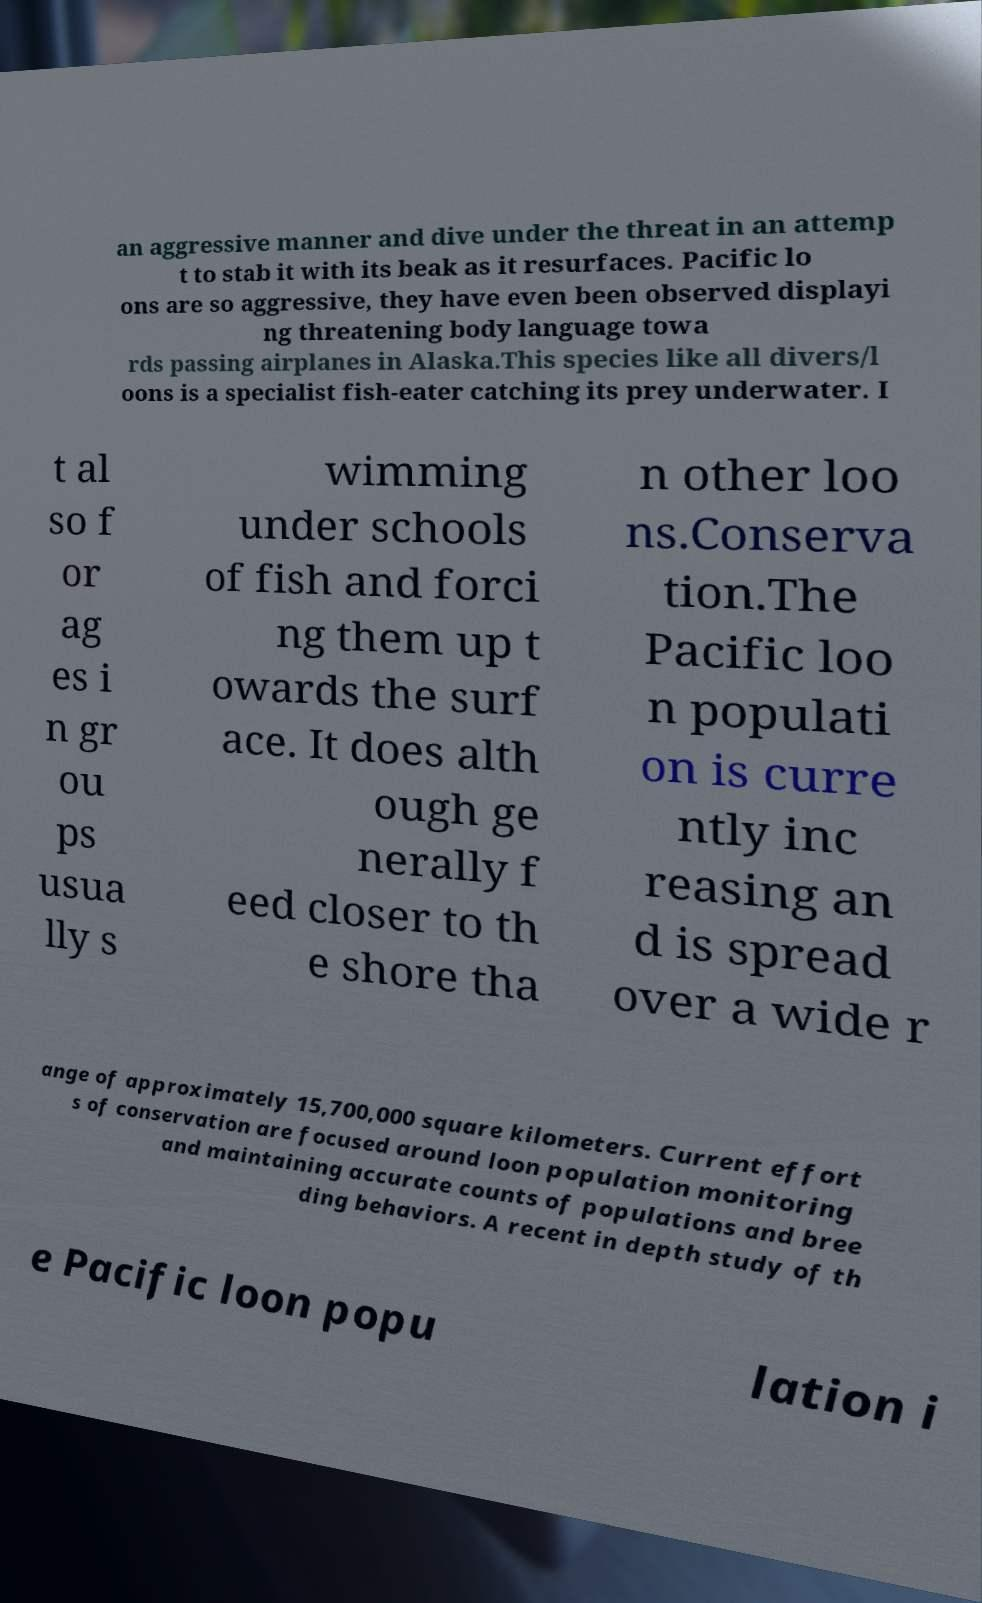Could you extract and type out the text from this image? an aggressive manner and dive under the threat in an attemp t to stab it with its beak as it resurfaces. Pacific lo ons are so aggressive, they have even been observed displayi ng threatening body language towa rds passing airplanes in Alaska.This species like all divers/l oons is a specialist fish-eater catching its prey underwater. I t al so f or ag es i n gr ou ps usua lly s wimming under schools of fish and forci ng them up t owards the surf ace. It does alth ough ge nerally f eed closer to th e shore tha n other loo ns.Conserva tion.The Pacific loo n populati on is curre ntly inc reasing an d is spread over a wide r ange of approximately 15,700,000 square kilometers. Current effort s of conservation are focused around loon population monitoring and maintaining accurate counts of populations and bree ding behaviors. A recent in depth study of th e Pacific loon popu lation i 